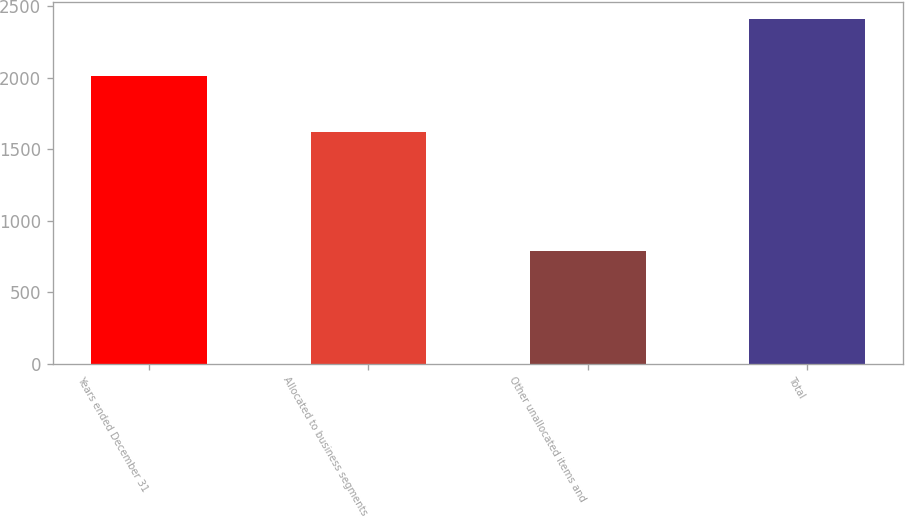Convert chart to OTSL. <chart><loc_0><loc_0><loc_500><loc_500><bar_chart><fcel>Years ended December 31<fcel>Allocated to business segments<fcel>Other unallocated items and<fcel>Total<nl><fcel>2012<fcel>1620<fcel>787<fcel>2407<nl></chart> 